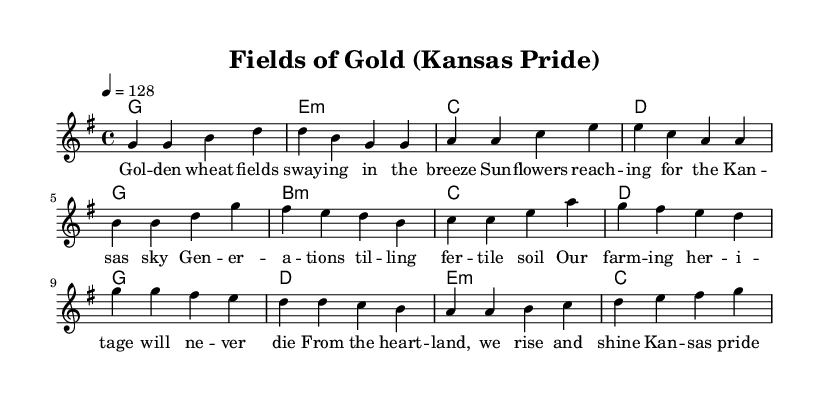What is the key signature of this music? The key signature is G major, which has one sharp (F#). It can be identified by looking at the key signature indicated at the beginning of the score.
Answer: G major What is the time signature of the piece? The time signature is 4/4, which can be found directly in the score. It indicates that there are four beats in each measure and a quarter note receives one beat.
Answer: 4/4 What is the tempo marking for the piece? The tempo marking is 128 beats per minute. It is specified in the score as "4 = 128," indicating the speed at which the piece should be played.
Answer: 128 What is the first note of the chorus? The first note of the chorus, as indicated in the melody section, is G. This can be found by looking at the melody's notes specifically starting from the chorus section.
Answer: G How many measures are there in the pre-chorus? There are four measures in the pre-chorus, as indicated in the score. Each section is divided clearly, and you can count the measures from the pre-chorus section of the melody.
Answer: 4 What themes do the lyrics of the song reflect? The lyrics reflect themes of agriculture and farming heritage. Words like "wheat," "Kansas," and "farming heritage" highlight this focus in the text.
Answer: Agriculture Which chord follows the first measure of the verse? The chord following the first measure of the verse is an E minor chord, as shown in the chord changes indicated in the score.
Answer: E minor 